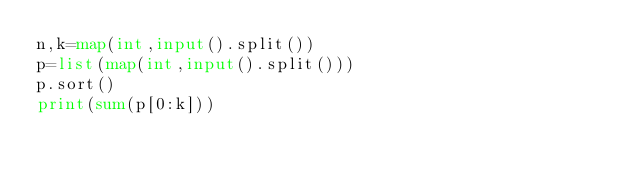<code> <loc_0><loc_0><loc_500><loc_500><_Python_>n,k=map(int,input().split())
p=list(map(int,input().split()))
p.sort()
print(sum(p[0:k]))</code> 